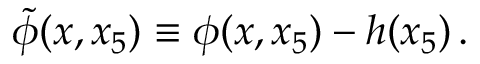Convert formula to latex. <formula><loc_0><loc_0><loc_500><loc_500>\tilde { \phi } ( x , x _ { 5 } ) \equiv \phi ( x , x _ { 5 } ) - h ( x _ { 5 } ) \, .</formula> 